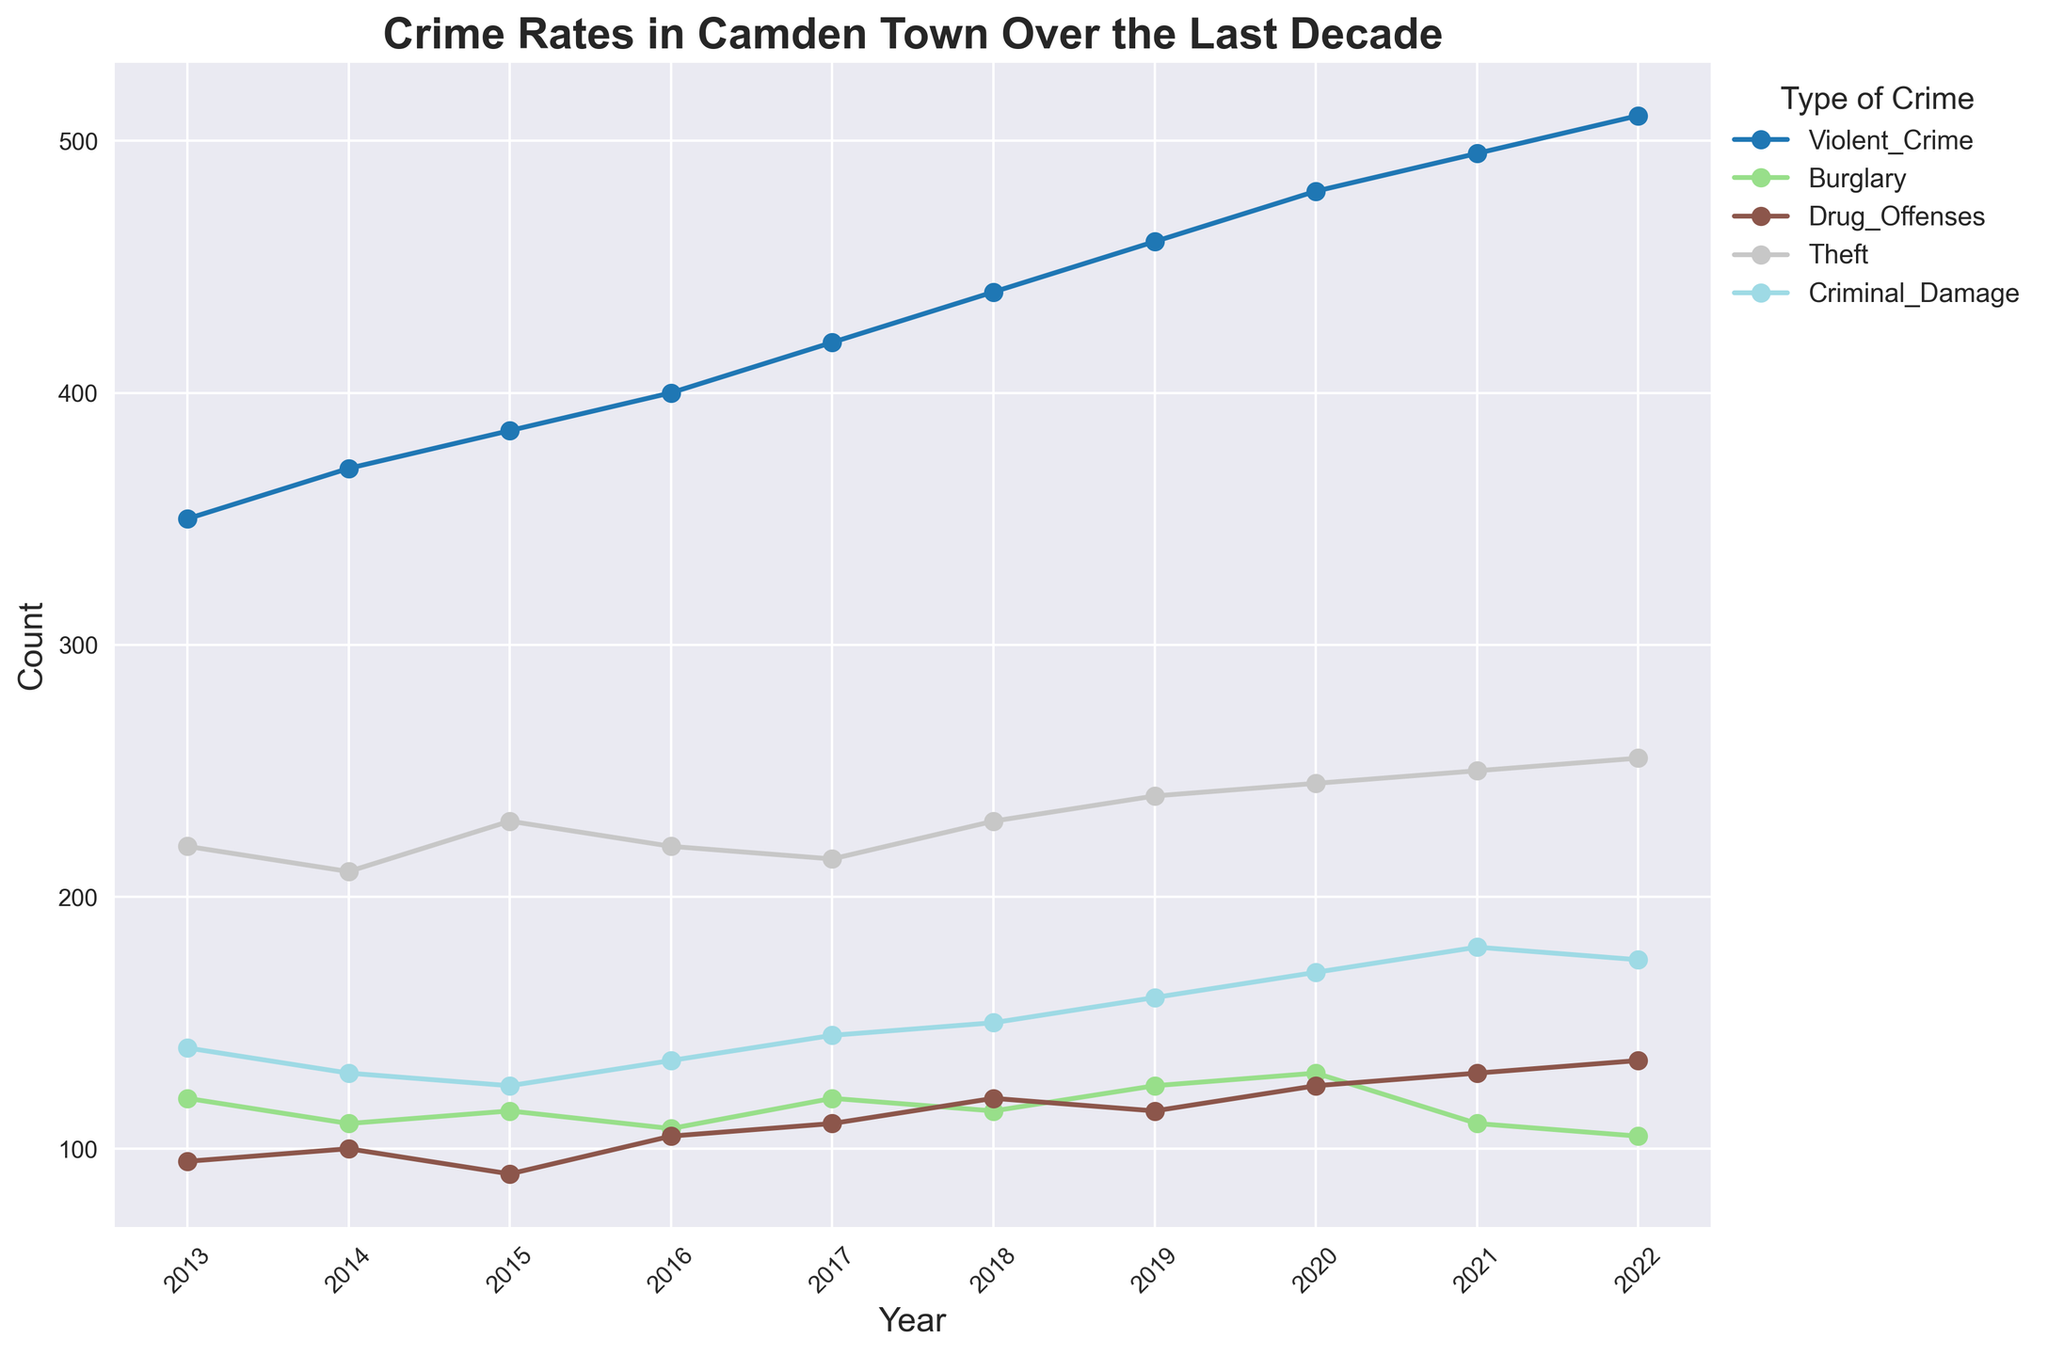What is the overall trend for violent crimes over the last decade? By observing the graph, we can see that the line for Violent Crime continuously rises from 2013 to 2022. This shows a consistent upward trend in violent crimes over the period.
Answer: Consistent increase Which year had the highest number of drug offenses? Looking at the data points for Drug Offenses across all years, the highest point is in 2022, with 135 offenses.
Answer: 2022 How did burglaries change from 2013 to 2022? To find how burglaries have changed, we can compare the counts in 2013 (120) to those in 2022 (105). This shows a decrease of 15 burglaries over the decade.
Answer: Decreased Which type of crime saw the greatest increase between 2013 and 2022? By comparing the data points for each crime type, we note the difference between the counts in 2013 and 2022. Violent Crime increased from 350 to 510, indicating the greatest increase of 160.
Answer: Violent Crime What was the average count of thefts from 2013 to 2022? The counts for Theft from 2013 to 2022 are: [220, 210, 230, 220, 215, 230, 240, 245, 250, 255]. Summing these values gives 2315, and dividing by 10 gives an average of 231.5.
Answer: 231.5 In which year was the count for criminal damage the lowest? Reviewing the graph for Criminal Damage, the lowest point is in 2015, with 125 incidents.
Answer: 2015 Compare the counts of drug offenses and burglaries in 2020. Which was higher? From the graph, in 2020, the count for Drug Offenses is 125 and for Burglary is 130. Since 130 is higher than 125, burglaries were higher in that year.
Answer: Burglaries Which type of crime had a count exactly equal to another type of crime in 2017? By checking the data, we see that Burglary and Criminal Damage both had a count of 120 in 2017.
Answer: Burglary and Criminal Damage What's the total number of violent crimes recorded from 2013 to 2022? The counts of Violent Crimes from 2013 to 2022 are: [350, 370, 385, 400, 420, 440, 460, 480, 495, 510]. Summing these gives a total of 4310.
Answer: 4310 How did the number of crimes labeled as "Theft" change between 2016 and 2021? Looking at the graph, the count for Theft was 220 in 2016 and 250 in 2021, showing an increase of 30.
Answer: Increased by 30 